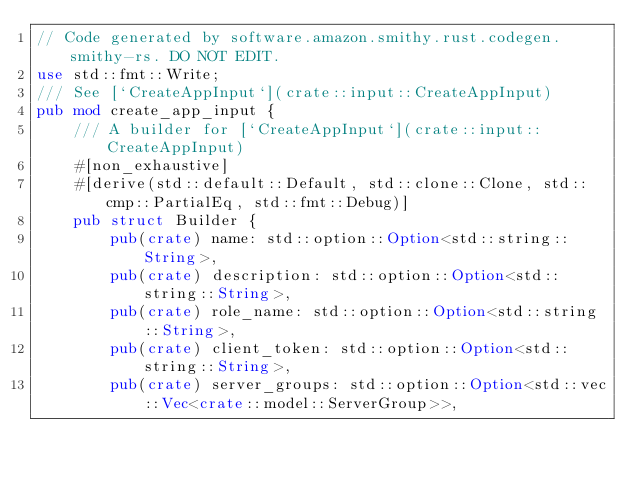Convert code to text. <code><loc_0><loc_0><loc_500><loc_500><_Rust_>// Code generated by software.amazon.smithy.rust.codegen.smithy-rs. DO NOT EDIT.
use std::fmt::Write;
/// See [`CreateAppInput`](crate::input::CreateAppInput)
pub mod create_app_input {
    /// A builder for [`CreateAppInput`](crate::input::CreateAppInput)
    #[non_exhaustive]
    #[derive(std::default::Default, std::clone::Clone, std::cmp::PartialEq, std::fmt::Debug)]
    pub struct Builder {
        pub(crate) name: std::option::Option<std::string::String>,
        pub(crate) description: std::option::Option<std::string::String>,
        pub(crate) role_name: std::option::Option<std::string::String>,
        pub(crate) client_token: std::option::Option<std::string::String>,
        pub(crate) server_groups: std::option::Option<std::vec::Vec<crate::model::ServerGroup>>,</code> 